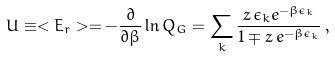Convert formula to latex. <formula><loc_0><loc_0><loc_500><loc_500>U \equiv < E _ { r } > = - \frac { \partial } { \partial \beta } \ln Q _ { G } = \sum _ { k } \frac { z \, \epsilon _ { k } e ^ { - \beta \epsilon _ { k } } } { 1 \mp z \, e ^ { - \beta \epsilon _ { k } } } \, ,</formula> 